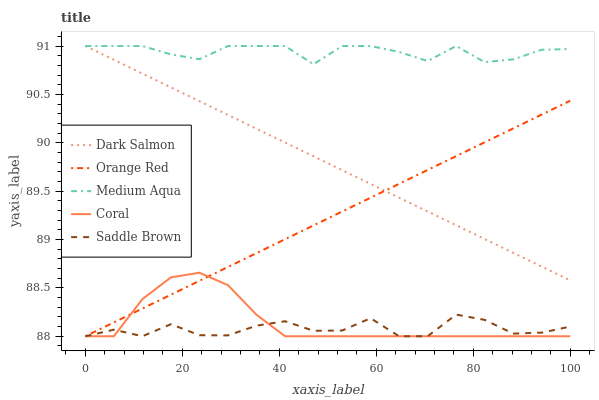Does Saddle Brown have the minimum area under the curve?
Answer yes or no. Yes. Does Medium Aqua have the maximum area under the curve?
Answer yes or no. Yes. Does Coral have the minimum area under the curve?
Answer yes or no. No. Does Coral have the maximum area under the curve?
Answer yes or no. No. Is Dark Salmon the smoothest?
Answer yes or no. Yes. Is Saddle Brown the roughest?
Answer yes or no. Yes. Is Coral the smoothest?
Answer yes or no. No. Is Coral the roughest?
Answer yes or no. No. Does Saddle Brown have the lowest value?
Answer yes or no. Yes. Does Medium Aqua have the lowest value?
Answer yes or no. No. Does Dark Salmon have the highest value?
Answer yes or no. Yes. Does Coral have the highest value?
Answer yes or no. No. Is Coral less than Dark Salmon?
Answer yes or no. Yes. Is Medium Aqua greater than Coral?
Answer yes or no. Yes. Does Orange Red intersect Coral?
Answer yes or no. Yes. Is Orange Red less than Coral?
Answer yes or no. No. Is Orange Red greater than Coral?
Answer yes or no. No. Does Coral intersect Dark Salmon?
Answer yes or no. No. 